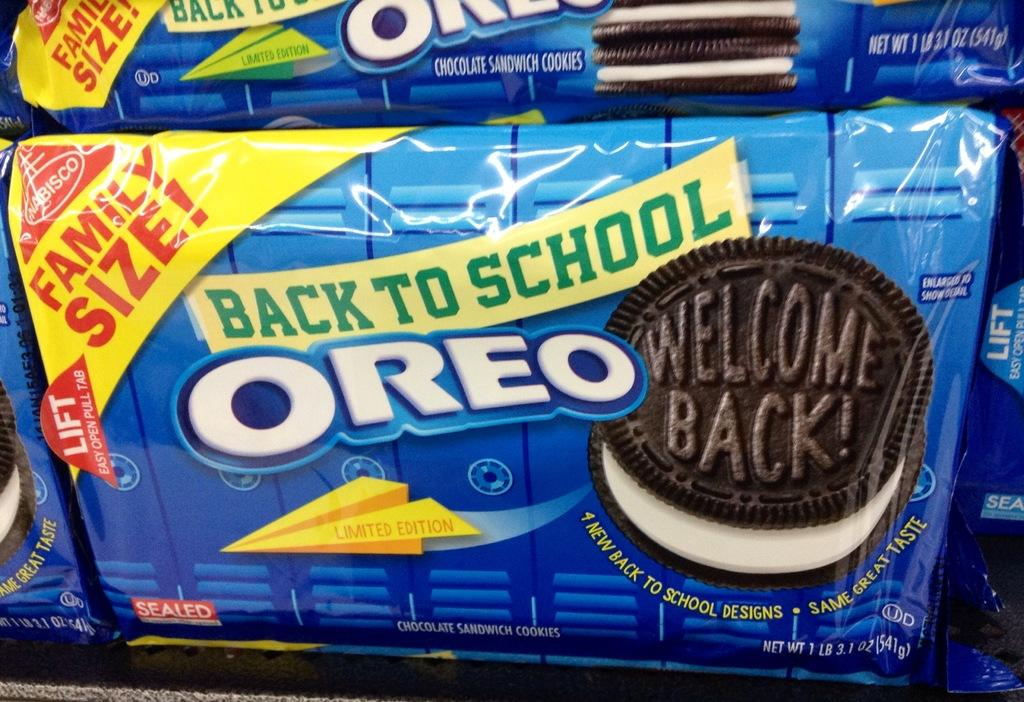<image>
Describe the image concisely. The back to school packaging for Oreo cookies. 